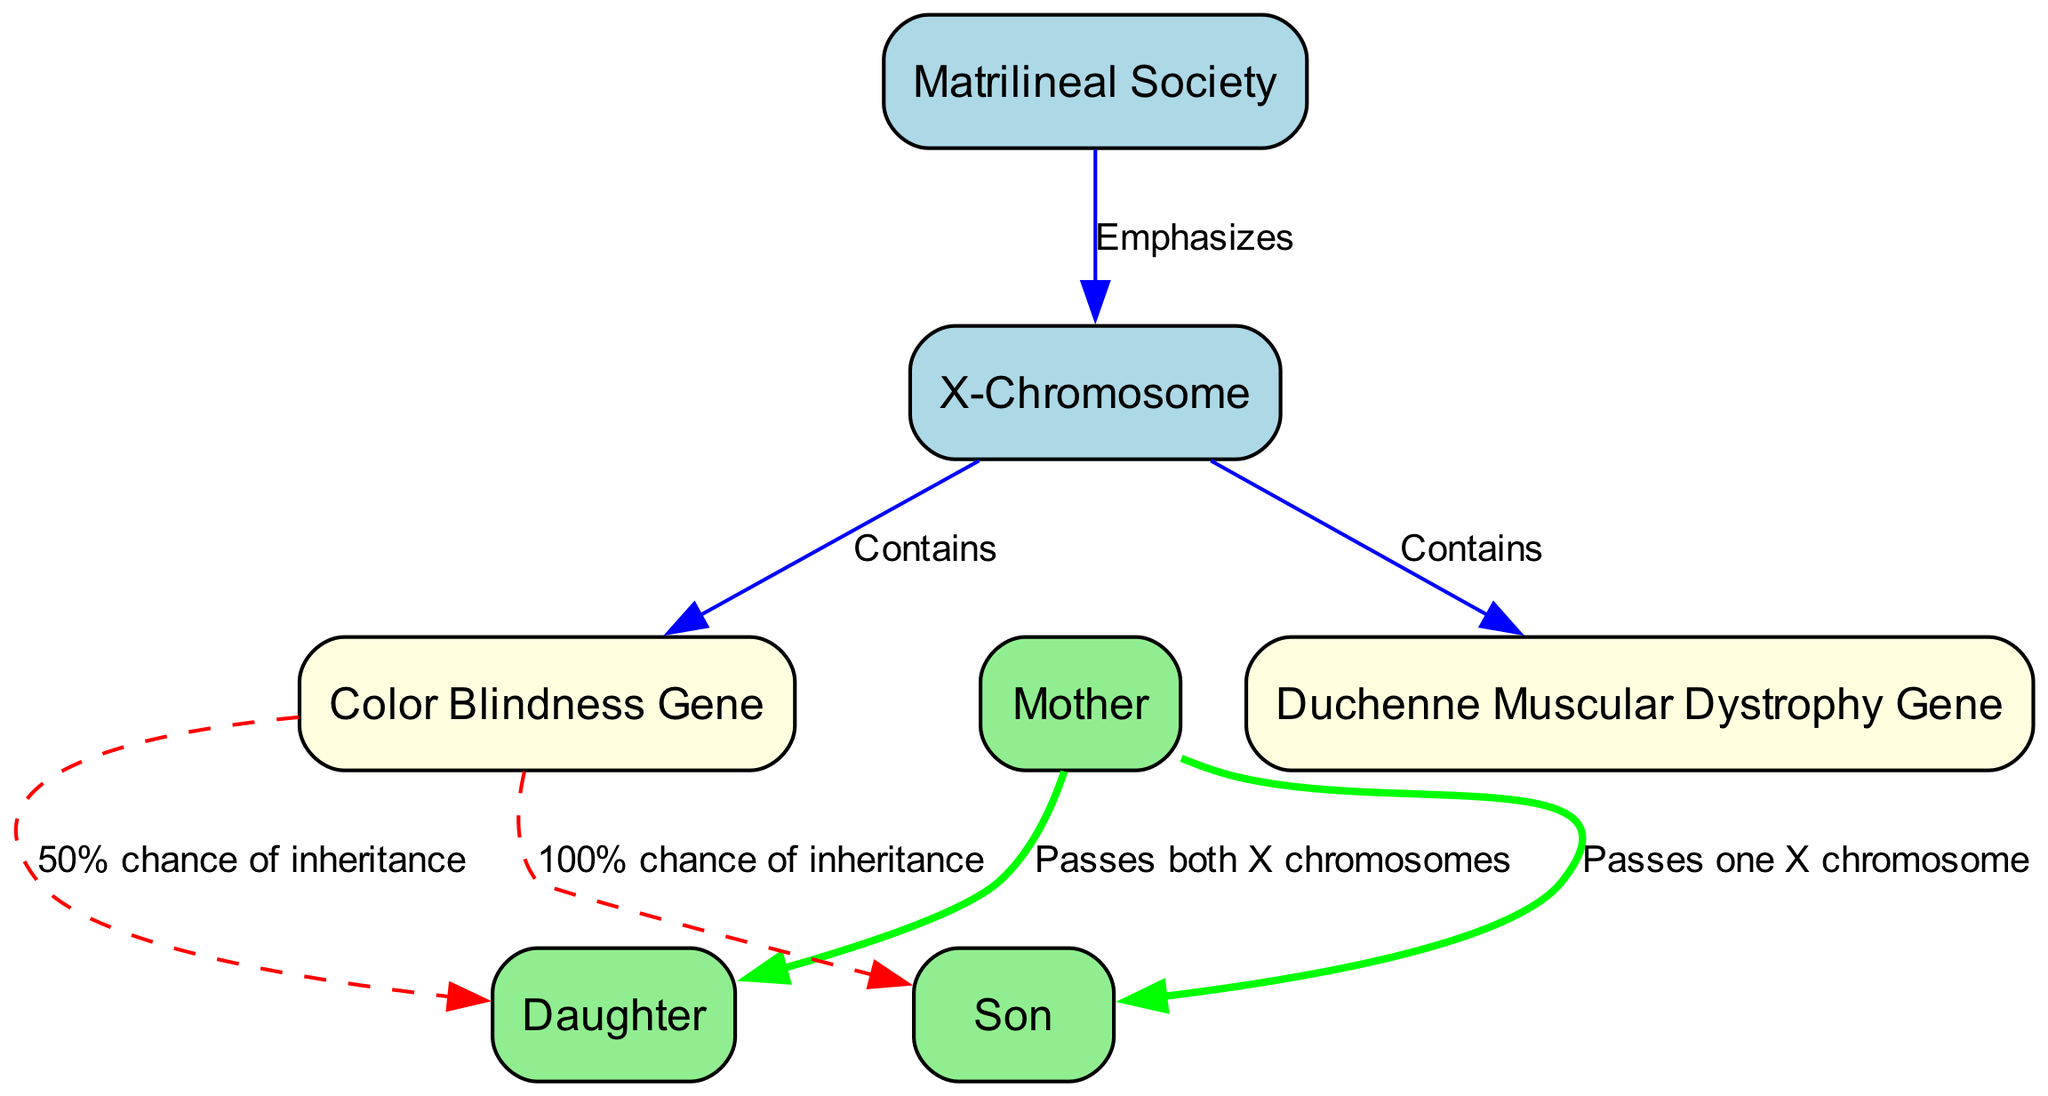What is the primary focus of the diagram? The diagram emphasizes the relationship between matrilineal societies and the inheritance of traits linked to the X-chromosome. The first node clearly states "Matrilineal Society," which connects to the "X-Chromosome" node.
Answer: Matrilineal Society How many total nodes are present in the diagram? By counting all the identified nodes, there are a total of seven nodes represented in the diagram, including the matrilineal society, X-chromosome, mother, daughter, son, color blindness gene, and Duchenne muscular dystrophy gene.
Answer: Seven What is the relationship between the mother and the daughter? The diagram specifies that the mother passes both X chromosomes to her daughter, creating a direct connection labeled accordingly. This is stated in the appropriate edge connecting these two nodes.
Answer: Passes both X chromosomes What is the inheritance chance of the color blindness gene for the daughter? The diagram illustrates that there is a 50% chance that the daughter will inherit the color blindness gene from her mother. This can be found on the edge connecting the color blindness gene and daughter nodes.
Answer: 50% Who is guaranteed to inherit the color blindness gene? According to the diagram, the son is guaranteed to inherit the color blindness gene because he receives one X chromosome from his mother, which may carry the gene. This is specified by the edge connecting these nodes.
Answer: 100% What genetic traits are linked to the X-chromosome in this diagram? The diagram shows that the X-chromosome contains the "Color Blindness Gene" and the "Duchenne Muscular Dystrophy Gene." These genes are defined as traits connected to the X-chromosome in the diagram.
Answer: Color Blindness Gene, Duchenne Muscular Dystrophy Gene What does the edge labeled “Passes one X chromosome” indicate? This edge indicates that a mother passes one X chromosome to her son. The corresponding edge in the diagram labels this relationship clearly, illustrating how inheritance works for males in this matrilineal context.
Answer: Passes one X chromosome If a mother is a carrier of the color blindness gene, what are the chances she will pass it to her son? From the diagram, it is evident that there is a 100% chance of inheritance for the son, as he receives the X chromosome from his mother that potentially carries the color blindness gene.
Answer: 100% What source of inheritance reinforces the matrilineal structure? The diagram illustrates that the matrilineal society emphasizes the transmission of genetic traits through the mother, leading to specific inheritance patterns. The directed edges from mother to children show this transmission clearly.
Answer: Mother 